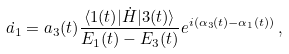Convert formula to latex. <formula><loc_0><loc_0><loc_500><loc_500>\dot { a _ { 1 } } = a _ { 3 } ( t ) \frac { \langle 1 ( t ) | \dot { H } | 3 ( t ) \rangle } { E _ { 1 } ( t ) - E _ { 3 } ( t ) } e ^ { i ( \alpha _ { 3 } ( t ) - \alpha _ { 1 } ( t ) ) } \, ,</formula> 